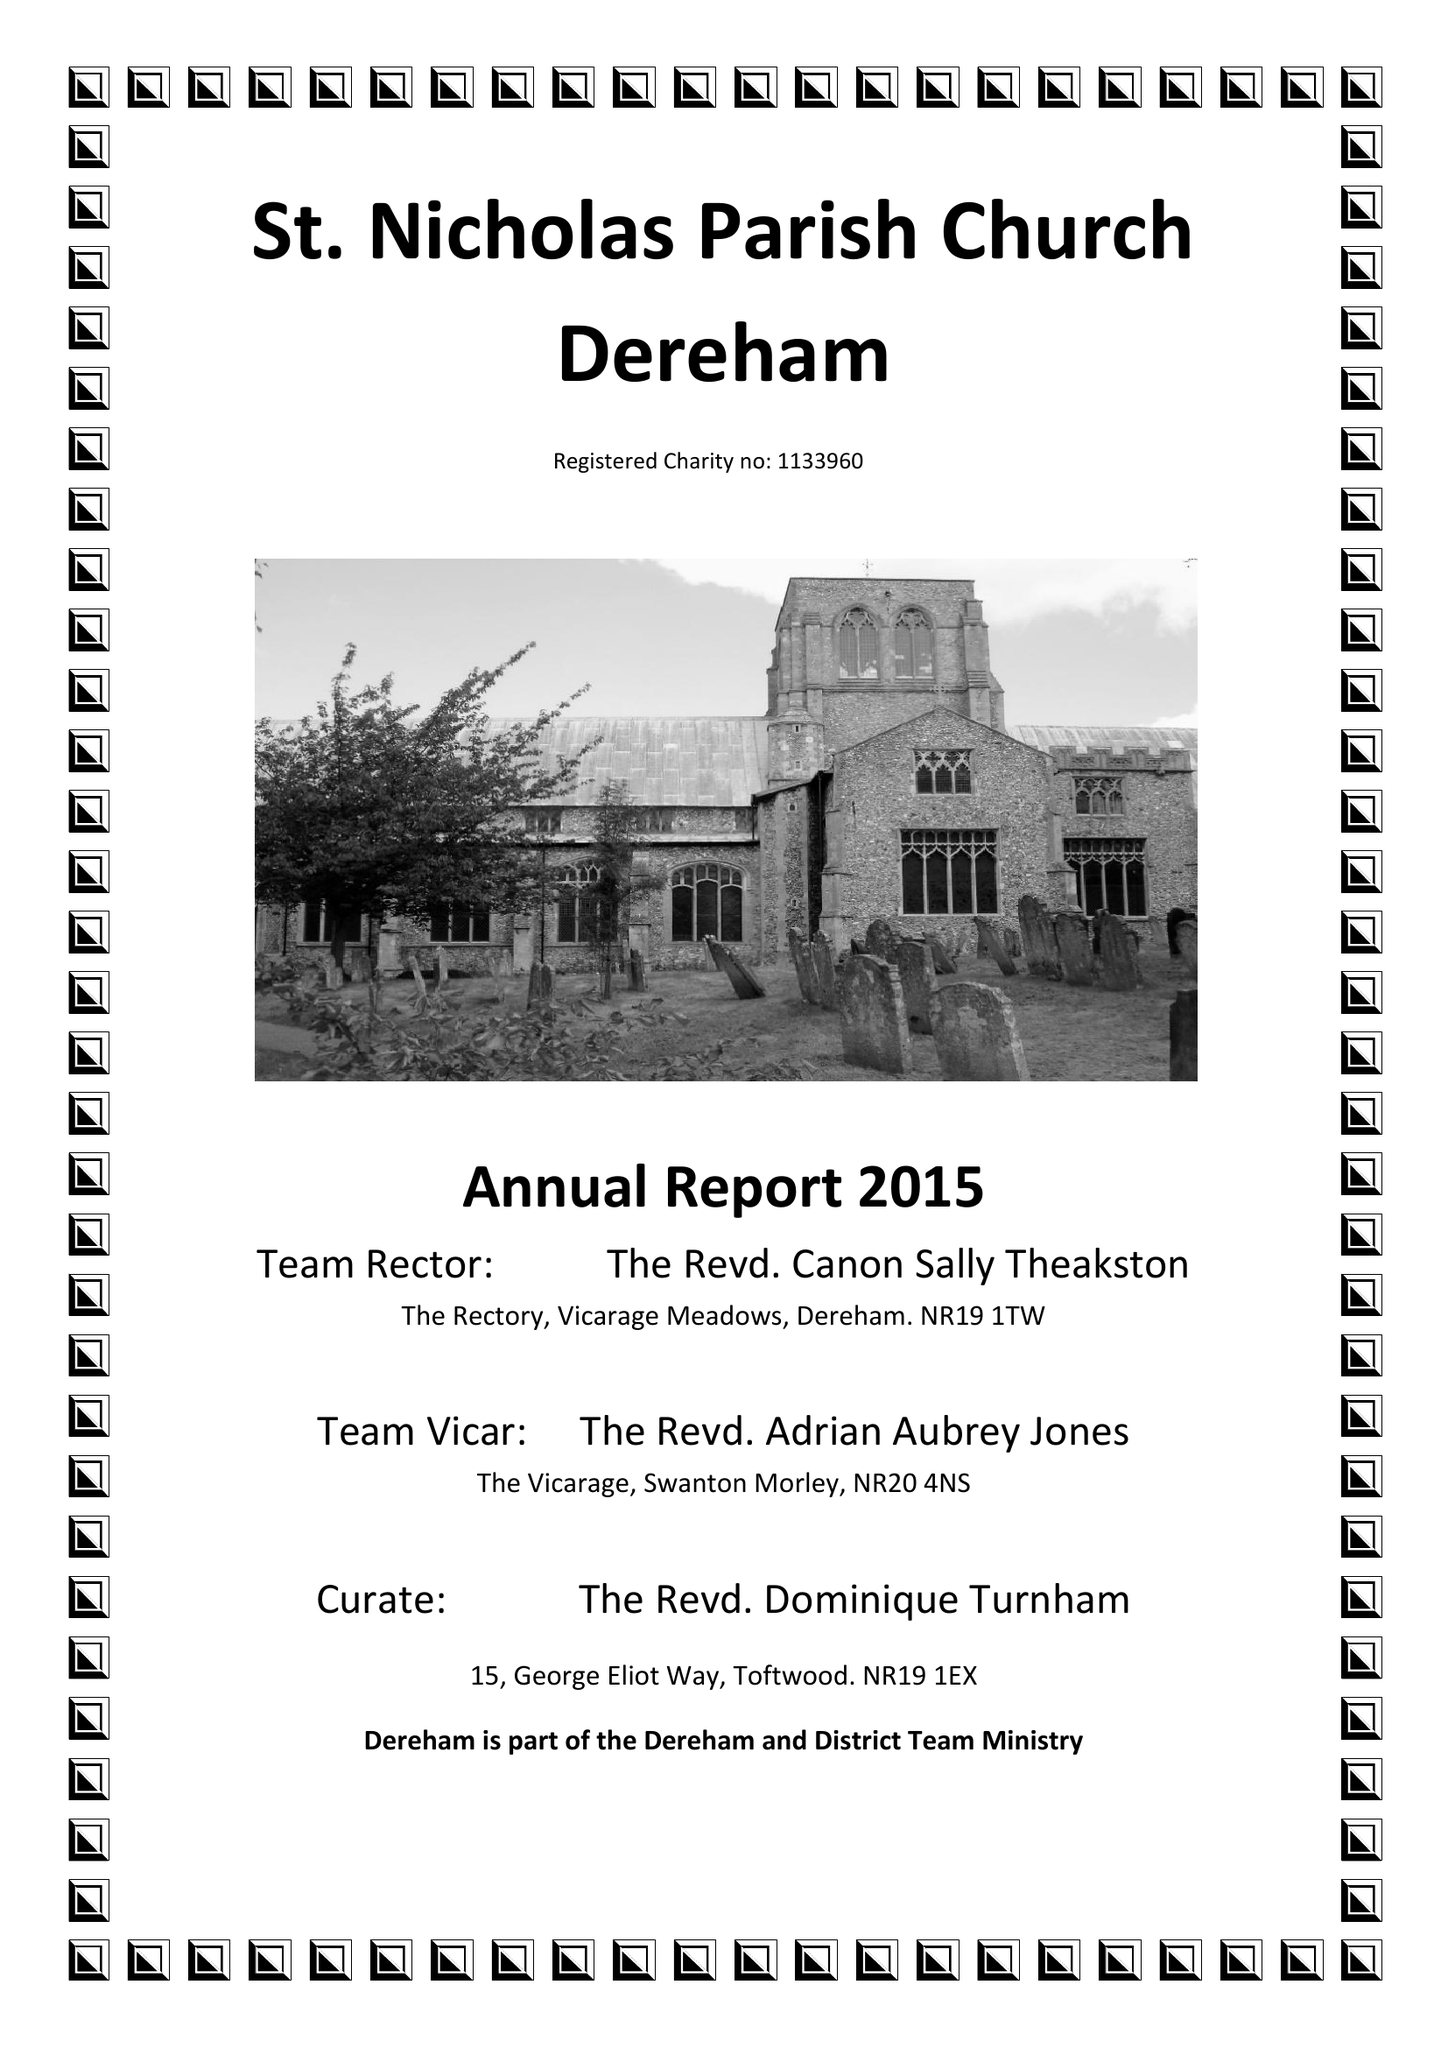What is the value for the charity_name?
Answer the question using a single word or phrase. The Parochial Church Council Of The Ecclesiastical Parish Of St Nicholas, Dereham 